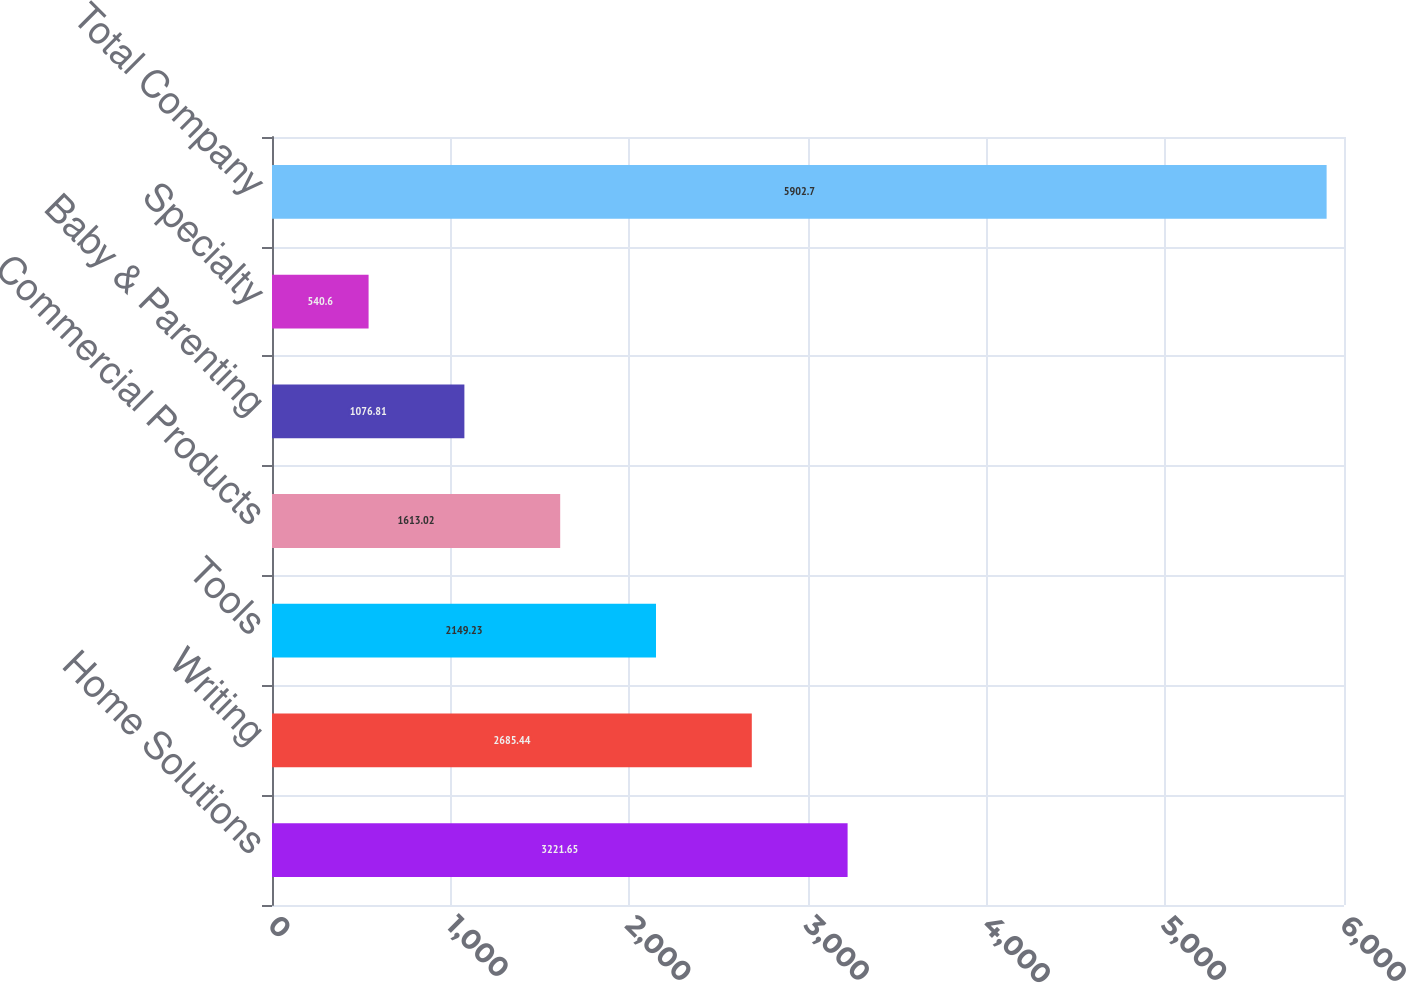Convert chart to OTSL. <chart><loc_0><loc_0><loc_500><loc_500><bar_chart><fcel>Home Solutions<fcel>Writing<fcel>Tools<fcel>Commercial Products<fcel>Baby & Parenting<fcel>Specialty<fcel>Total Company<nl><fcel>3221.65<fcel>2685.44<fcel>2149.23<fcel>1613.02<fcel>1076.81<fcel>540.6<fcel>5902.7<nl></chart> 